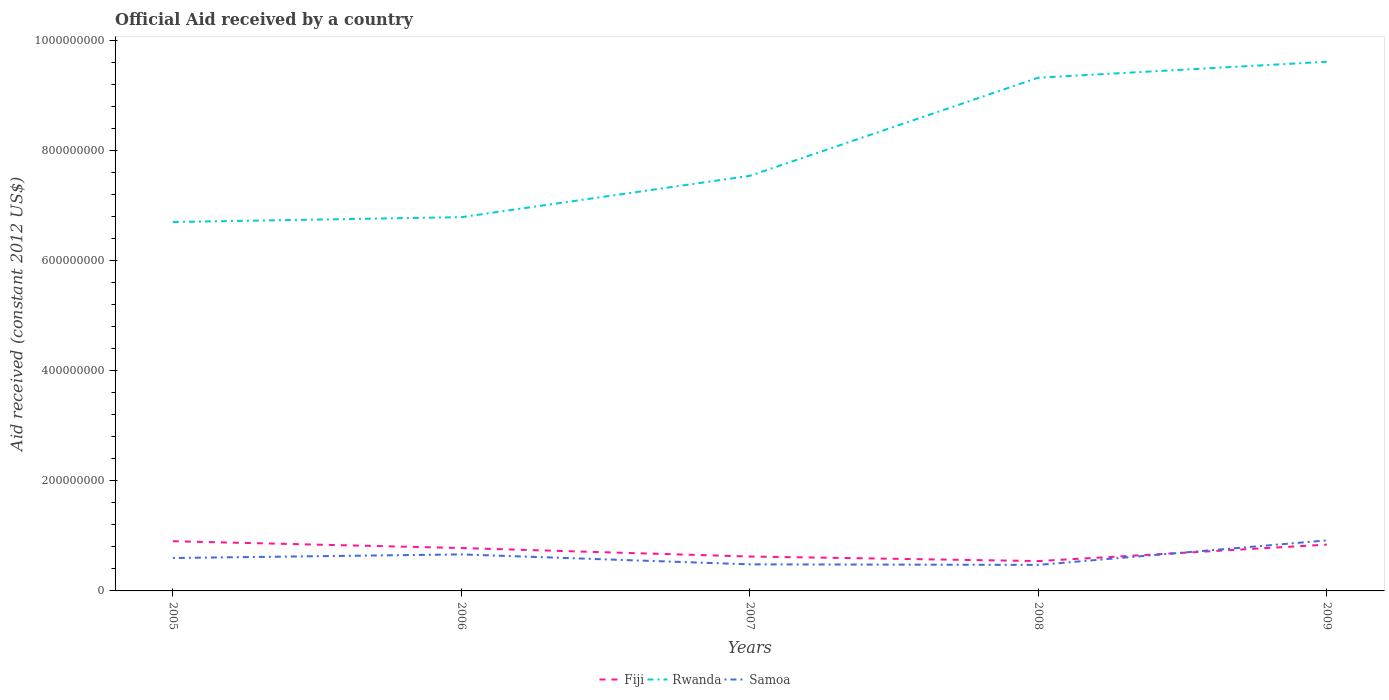How many different coloured lines are there?
Your answer should be very brief. 3. Does the line corresponding to Fiji intersect with the line corresponding to Samoa?
Provide a succinct answer. Yes. Across all years, what is the maximum net official aid received in Rwanda?
Offer a terse response. 6.70e+08. What is the total net official aid received in Fiji in the graph?
Make the answer very short. -2.99e+07. What is the difference between the highest and the second highest net official aid received in Samoa?
Your answer should be very brief. 4.45e+07. Is the net official aid received in Samoa strictly greater than the net official aid received in Rwanda over the years?
Your answer should be compact. Yes. How many lines are there?
Ensure brevity in your answer.  3. How many years are there in the graph?
Make the answer very short. 5. Are the values on the major ticks of Y-axis written in scientific E-notation?
Keep it short and to the point. No. Where does the legend appear in the graph?
Your answer should be very brief. Bottom center. How many legend labels are there?
Offer a very short reply. 3. How are the legend labels stacked?
Your response must be concise. Horizontal. What is the title of the graph?
Ensure brevity in your answer.  Official Aid received by a country. Does "Bangladesh" appear as one of the legend labels in the graph?
Your answer should be compact. No. What is the label or title of the X-axis?
Your answer should be compact. Years. What is the label or title of the Y-axis?
Your response must be concise. Aid received (constant 2012 US$). What is the Aid received (constant 2012 US$) in Fiji in 2005?
Offer a very short reply. 9.03e+07. What is the Aid received (constant 2012 US$) in Rwanda in 2005?
Provide a succinct answer. 6.70e+08. What is the Aid received (constant 2012 US$) of Samoa in 2005?
Give a very brief answer. 5.98e+07. What is the Aid received (constant 2012 US$) in Fiji in 2006?
Keep it short and to the point. 7.79e+07. What is the Aid received (constant 2012 US$) of Rwanda in 2006?
Ensure brevity in your answer.  6.79e+08. What is the Aid received (constant 2012 US$) in Samoa in 2006?
Your answer should be compact. 6.63e+07. What is the Aid received (constant 2012 US$) of Fiji in 2007?
Give a very brief answer. 6.25e+07. What is the Aid received (constant 2012 US$) of Rwanda in 2007?
Provide a succinct answer. 7.54e+08. What is the Aid received (constant 2012 US$) of Samoa in 2007?
Provide a succinct answer. 4.83e+07. What is the Aid received (constant 2012 US$) of Fiji in 2008?
Keep it short and to the point. 5.42e+07. What is the Aid received (constant 2012 US$) of Rwanda in 2008?
Keep it short and to the point. 9.32e+08. What is the Aid received (constant 2012 US$) of Samoa in 2008?
Provide a succinct answer. 4.73e+07. What is the Aid received (constant 2012 US$) in Fiji in 2009?
Offer a terse response. 8.41e+07. What is the Aid received (constant 2012 US$) in Rwanda in 2009?
Your response must be concise. 9.61e+08. What is the Aid received (constant 2012 US$) in Samoa in 2009?
Your answer should be compact. 9.18e+07. Across all years, what is the maximum Aid received (constant 2012 US$) of Fiji?
Provide a short and direct response. 9.03e+07. Across all years, what is the maximum Aid received (constant 2012 US$) in Rwanda?
Offer a terse response. 9.61e+08. Across all years, what is the maximum Aid received (constant 2012 US$) of Samoa?
Provide a short and direct response. 9.18e+07. Across all years, what is the minimum Aid received (constant 2012 US$) in Fiji?
Make the answer very short. 5.42e+07. Across all years, what is the minimum Aid received (constant 2012 US$) of Rwanda?
Offer a terse response. 6.70e+08. Across all years, what is the minimum Aid received (constant 2012 US$) in Samoa?
Offer a very short reply. 4.73e+07. What is the total Aid received (constant 2012 US$) in Fiji in the graph?
Offer a terse response. 3.69e+08. What is the total Aid received (constant 2012 US$) of Rwanda in the graph?
Your response must be concise. 4.00e+09. What is the total Aid received (constant 2012 US$) of Samoa in the graph?
Keep it short and to the point. 3.13e+08. What is the difference between the Aid received (constant 2012 US$) in Fiji in 2005 and that in 2006?
Provide a short and direct response. 1.24e+07. What is the difference between the Aid received (constant 2012 US$) in Rwanda in 2005 and that in 2006?
Offer a terse response. -8.83e+06. What is the difference between the Aid received (constant 2012 US$) of Samoa in 2005 and that in 2006?
Your response must be concise. -6.54e+06. What is the difference between the Aid received (constant 2012 US$) in Fiji in 2005 and that in 2007?
Give a very brief answer. 2.78e+07. What is the difference between the Aid received (constant 2012 US$) of Rwanda in 2005 and that in 2007?
Make the answer very short. -8.39e+07. What is the difference between the Aid received (constant 2012 US$) in Samoa in 2005 and that in 2007?
Provide a short and direct response. 1.15e+07. What is the difference between the Aid received (constant 2012 US$) in Fiji in 2005 and that in 2008?
Make the answer very short. 3.60e+07. What is the difference between the Aid received (constant 2012 US$) of Rwanda in 2005 and that in 2008?
Provide a short and direct response. -2.62e+08. What is the difference between the Aid received (constant 2012 US$) in Samoa in 2005 and that in 2008?
Provide a short and direct response. 1.25e+07. What is the difference between the Aid received (constant 2012 US$) of Fiji in 2005 and that in 2009?
Make the answer very short. 6.16e+06. What is the difference between the Aid received (constant 2012 US$) in Rwanda in 2005 and that in 2009?
Offer a very short reply. -2.91e+08. What is the difference between the Aid received (constant 2012 US$) in Samoa in 2005 and that in 2009?
Make the answer very short. -3.20e+07. What is the difference between the Aid received (constant 2012 US$) in Fiji in 2006 and that in 2007?
Ensure brevity in your answer.  1.54e+07. What is the difference between the Aid received (constant 2012 US$) in Rwanda in 2006 and that in 2007?
Make the answer very short. -7.50e+07. What is the difference between the Aid received (constant 2012 US$) of Samoa in 2006 and that in 2007?
Offer a very short reply. 1.80e+07. What is the difference between the Aid received (constant 2012 US$) in Fiji in 2006 and that in 2008?
Make the answer very short. 2.37e+07. What is the difference between the Aid received (constant 2012 US$) of Rwanda in 2006 and that in 2008?
Give a very brief answer. -2.53e+08. What is the difference between the Aid received (constant 2012 US$) in Samoa in 2006 and that in 2008?
Make the answer very short. 1.91e+07. What is the difference between the Aid received (constant 2012 US$) in Fiji in 2006 and that in 2009?
Provide a succinct answer. -6.22e+06. What is the difference between the Aid received (constant 2012 US$) of Rwanda in 2006 and that in 2009?
Your answer should be compact. -2.82e+08. What is the difference between the Aid received (constant 2012 US$) in Samoa in 2006 and that in 2009?
Keep it short and to the point. -2.54e+07. What is the difference between the Aid received (constant 2012 US$) of Fiji in 2007 and that in 2008?
Your answer should be very brief. 8.26e+06. What is the difference between the Aid received (constant 2012 US$) in Rwanda in 2007 and that in 2008?
Keep it short and to the point. -1.78e+08. What is the difference between the Aid received (constant 2012 US$) of Samoa in 2007 and that in 2008?
Offer a very short reply. 1.01e+06. What is the difference between the Aid received (constant 2012 US$) of Fiji in 2007 and that in 2009?
Your answer should be very brief. -2.16e+07. What is the difference between the Aid received (constant 2012 US$) of Rwanda in 2007 and that in 2009?
Make the answer very short. -2.07e+08. What is the difference between the Aid received (constant 2012 US$) of Samoa in 2007 and that in 2009?
Your answer should be compact. -4.35e+07. What is the difference between the Aid received (constant 2012 US$) in Fiji in 2008 and that in 2009?
Provide a short and direct response. -2.99e+07. What is the difference between the Aid received (constant 2012 US$) of Rwanda in 2008 and that in 2009?
Give a very brief answer. -2.90e+07. What is the difference between the Aid received (constant 2012 US$) of Samoa in 2008 and that in 2009?
Your answer should be very brief. -4.45e+07. What is the difference between the Aid received (constant 2012 US$) of Fiji in 2005 and the Aid received (constant 2012 US$) of Rwanda in 2006?
Keep it short and to the point. -5.89e+08. What is the difference between the Aid received (constant 2012 US$) in Fiji in 2005 and the Aid received (constant 2012 US$) in Samoa in 2006?
Keep it short and to the point. 2.40e+07. What is the difference between the Aid received (constant 2012 US$) in Rwanda in 2005 and the Aid received (constant 2012 US$) in Samoa in 2006?
Keep it short and to the point. 6.04e+08. What is the difference between the Aid received (constant 2012 US$) of Fiji in 2005 and the Aid received (constant 2012 US$) of Rwanda in 2007?
Your answer should be compact. -6.64e+08. What is the difference between the Aid received (constant 2012 US$) in Fiji in 2005 and the Aid received (constant 2012 US$) in Samoa in 2007?
Your answer should be compact. 4.20e+07. What is the difference between the Aid received (constant 2012 US$) of Rwanda in 2005 and the Aid received (constant 2012 US$) of Samoa in 2007?
Provide a succinct answer. 6.22e+08. What is the difference between the Aid received (constant 2012 US$) of Fiji in 2005 and the Aid received (constant 2012 US$) of Rwanda in 2008?
Ensure brevity in your answer.  -8.42e+08. What is the difference between the Aid received (constant 2012 US$) of Fiji in 2005 and the Aid received (constant 2012 US$) of Samoa in 2008?
Offer a very short reply. 4.30e+07. What is the difference between the Aid received (constant 2012 US$) of Rwanda in 2005 and the Aid received (constant 2012 US$) of Samoa in 2008?
Offer a terse response. 6.23e+08. What is the difference between the Aid received (constant 2012 US$) of Fiji in 2005 and the Aid received (constant 2012 US$) of Rwanda in 2009?
Make the answer very short. -8.71e+08. What is the difference between the Aid received (constant 2012 US$) in Fiji in 2005 and the Aid received (constant 2012 US$) in Samoa in 2009?
Make the answer very short. -1.48e+06. What is the difference between the Aid received (constant 2012 US$) in Rwanda in 2005 and the Aid received (constant 2012 US$) in Samoa in 2009?
Ensure brevity in your answer.  5.78e+08. What is the difference between the Aid received (constant 2012 US$) in Fiji in 2006 and the Aid received (constant 2012 US$) in Rwanda in 2007?
Keep it short and to the point. -6.76e+08. What is the difference between the Aid received (constant 2012 US$) of Fiji in 2006 and the Aid received (constant 2012 US$) of Samoa in 2007?
Ensure brevity in your answer.  2.96e+07. What is the difference between the Aid received (constant 2012 US$) in Rwanda in 2006 and the Aid received (constant 2012 US$) in Samoa in 2007?
Provide a short and direct response. 6.31e+08. What is the difference between the Aid received (constant 2012 US$) in Fiji in 2006 and the Aid received (constant 2012 US$) in Rwanda in 2008?
Provide a short and direct response. -8.54e+08. What is the difference between the Aid received (constant 2012 US$) in Fiji in 2006 and the Aid received (constant 2012 US$) in Samoa in 2008?
Offer a very short reply. 3.06e+07. What is the difference between the Aid received (constant 2012 US$) of Rwanda in 2006 and the Aid received (constant 2012 US$) of Samoa in 2008?
Offer a very short reply. 6.32e+08. What is the difference between the Aid received (constant 2012 US$) of Fiji in 2006 and the Aid received (constant 2012 US$) of Rwanda in 2009?
Offer a terse response. -8.83e+08. What is the difference between the Aid received (constant 2012 US$) in Fiji in 2006 and the Aid received (constant 2012 US$) in Samoa in 2009?
Your response must be concise. -1.39e+07. What is the difference between the Aid received (constant 2012 US$) of Rwanda in 2006 and the Aid received (constant 2012 US$) of Samoa in 2009?
Give a very brief answer. 5.87e+08. What is the difference between the Aid received (constant 2012 US$) in Fiji in 2007 and the Aid received (constant 2012 US$) in Rwanda in 2008?
Provide a short and direct response. -8.70e+08. What is the difference between the Aid received (constant 2012 US$) in Fiji in 2007 and the Aid received (constant 2012 US$) in Samoa in 2008?
Offer a very short reply. 1.52e+07. What is the difference between the Aid received (constant 2012 US$) in Rwanda in 2007 and the Aid received (constant 2012 US$) in Samoa in 2008?
Offer a terse response. 7.07e+08. What is the difference between the Aid received (constant 2012 US$) of Fiji in 2007 and the Aid received (constant 2012 US$) of Rwanda in 2009?
Provide a succinct answer. -8.99e+08. What is the difference between the Aid received (constant 2012 US$) in Fiji in 2007 and the Aid received (constant 2012 US$) in Samoa in 2009?
Your response must be concise. -2.93e+07. What is the difference between the Aid received (constant 2012 US$) in Rwanda in 2007 and the Aid received (constant 2012 US$) in Samoa in 2009?
Keep it short and to the point. 6.62e+08. What is the difference between the Aid received (constant 2012 US$) of Fiji in 2008 and the Aid received (constant 2012 US$) of Rwanda in 2009?
Offer a terse response. -9.07e+08. What is the difference between the Aid received (constant 2012 US$) of Fiji in 2008 and the Aid received (constant 2012 US$) of Samoa in 2009?
Make the answer very short. -3.75e+07. What is the difference between the Aid received (constant 2012 US$) in Rwanda in 2008 and the Aid received (constant 2012 US$) in Samoa in 2009?
Provide a short and direct response. 8.40e+08. What is the average Aid received (constant 2012 US$) in Fiji per year?
Offer a very short reply. 7.38e+07. What is the average Aid received (constant 2012 US$) of Rwanda per year?
Give a very brief answer. 7.99e+08. What is the average Aid received (constant 2012 US$) of Samoa per year?
Make the answer very short. 6.27e+07. In the year 2005, what is the difference between the Aid received (constant 2012 US$) of Fiji and Aid received (constant 2012 US$) of Rwanda?
Ensure brevity in your answer.  -5.80e+08. In the year 2005, what is the difference between the Aid received (constant 2012 US$) of Fiji and Aid received (constant 2012 US$) of Samoa?
Make the answer very short. 3.05e+07. In the year 2005, what is the difference between the Aid received (constant 2012 US$) in Rwanda and Aid received (constant 2012 US$) in Samoa?
Give a very brief answer. 6.10e+08. In the year 2006, what is the difference between the Aid received (constant 2012 US$) in Fiji and Aid received (constant 2012 US$) in Rwanda?
Your answer should be compact. -6.01e+08. In the year 2006, what is the difference between the Aid received (constant 2012 US$) in Fiji and Aid received (constant 2012 US$) in Samoa?
Your answer should be very brief. 1.16e+07. In the year 2006, what is the difference between the Aid received (constant 2012 US$) in Rwanda and Aid received (constant 2012 US$) in Samoa?
Provide a short and direct response. 6.13e+08. In the year 2007, what is the difference between the Aid received (constant 2012 US$) in Fiji and Aid received (constant 2012 US$) in Rwanda?
Make the answer very short. -6.91e+08. In the year 2007, what is the difference between the Aid received (constant 2012 US$) of Fiji and Aid received (constant 2012 US$) of Samoa?
Provide a succinct answer. 1.42e+07. In the year 2007, what is the difference between the Aid received (constant 2012 US$) in Rwanda and Aid received (constant 2012 US$) in Samoa?
Ensure brevity in your answer.  7.06e+08. In the year 2008, what is the difference between the Aid received (constant 2012 US$) in Fiji and Aid received (constant 2012 US$) in Rwanda?
Your answer should be very brief. -8.78e+08. In the year 2008, what is the difference between the Aid received (constant 2012 US$) in Fiji and Aid received (constant 2012 US$) in Samoa?
Provide a short and direct response. 6.96e+06. In the year 2008, what is the difference between the Aid received (constant 2012 US$) of Rwanda and Aid received (constant 2012 US$) of Samoa?
Provide a succinct answer. 8.85e+08. In the year 2009, what is the difference between the Aid received (constant 2012 US$) of Fiji and Aid received (constant 2012 US$) of Rwanda?
Your answer should be very brief. -8.77e+08. In the year 2009, what is the difference between the Aid received (constant 2012 US$) in Fiji and Aid received (constant 2012 US$) in Samoa?
Your answer should be very brief. -7.64e+06. In the year 2009, what is the difference between the Aid received (constant 2012 US$) in Rwanda and Aid received (constant 2012 US$) in Samoa?
Ensure brevity in your answer.  8.69e+08. What is the ratio of the Aid received (constant 2012 US$) in Fiji in 2005 to that in 2006?
Your answer should be compact. 1.16. What is the ratio of the Aid received (constant 2012 US$) of Samoa in 2005 to that in 2006?
Offer a very short reply. 0.9. What is the ratio of the Aid received (constant 2012 US$) of Fiji in 2005 to that in 2007?
Provide a short and direct response. 1.44. What is the ratio of the Aid received (constant 2012 US$) of Rwanda in 2005 to that in 2007?
Offer a terse response. 0.89. What is the ratio of the Aid received (constant 2012 US$) in Samoa in 2005 to that in 2007?
Your response must be concise. 1.24. What is the ratio of the Aid received (constant 2012 US$) of Fiji in 2005 to that in 2008?
Ensure brevity in your answer.  1.66. What is the ratio of the Aid received (constant 2012 US$) of Rwanda in 2005 to that in 2008?
Offer a very short reply. 0.72. What is the ratio of the Aid received (constant 2012 US$) of Samoa in 2005 to that in 2008?
Your response must be concise. 1.26. What is the ratio of the Aid received (constant 2012 US$) of Fiji in 2005 to that in 2009?
Your response must be concise. 1.07. What is the ratio of the Aid received (constant 2012 US$) in Rwanda in 2005 to that in 2009?
Offer a very short reply. 0.7. What is the ratio of the Aid received (constant 2012 US$) in Samoa in 2005 to that in 2009?
Provide a short and direct response. 0.65. What is the ratio of the Aid received (constant 2012 US$) of Fiji in 2006 to that in 2007?
Your answer should be compact. 1.25. What is the ratio of the Aid received (constant 2012 US$) in Rwanda in 2006 to that in 2007?
Give a very brief answer. 0.9. What is the ratio of the Aid received (constant 2012 US$) of Samoa in 2006 to that in 2007?
Make the answer very short. 1.37. What is the ratio of the Aid received (constant 2012 US$) in Fiji in 2006 to that in 2008?
Your answer should be very brief. 1.44. What is the ratio of the Aid received (constant 2012 US$) in Rwanda in 2006 to that in 2008?
Your answer should be compact. 0.73. What is the ratio of the Aid received (constant 2012 US$) in Samoa in 2006 to that in 2008?
Provide a short and direct response. 1.4. What is the ratio of the Aid received (constant 2012 US$) of Fiji in 2006 to that in 2009?
Keep it short and to the point. 0.93. What is the ratio of the Aid received (constant 2012 US$) of Rwanda in 2006 to that in 2009?
Your answer should be compact. 0.71. What is the ratio of the Aid received (constant 2012 US$) in Samoa in 2006 to that in 2009?
Give a very brief answer. 0.72. What is the ratio of the Aid received (constant 2012 US$) in Fiji in 2007 to that in 2008?
Give a very brief answer. 1.15. What is the ratio of the Aid received (constant 2012 US$) of Rwanda in 2007 to that in 2008?
Your answer should be compact. 0.81. What is the ratio of the Aid received (constant 2012 US$) of Samoa in 2007 to that in 2008?
Your answer should be very brief. 1.02. What is the ratio of the Aid received (constant 2012 US$) in Fiji in 2007 to that in 2009?
Your response must be concise. 0.74. What is the ratio of the Aid received (constant 2012 US$) in Rwanda in 2007 to that in 2009?
Make the answer very short. 0.78. What is the ratio of the Aid received (constant 2012 US$) of Samoa in 2007 to that in 2009?
Offer a very short reply. 0.53. What is the ratio of the Aid received (constant 2012 US$) of Fiji in 2008 to that in 2009?
Provide a succinct answer. 0.64. What is the ratio of the Aid received (constant 2012 US$) of Rwanda in 2008 to that in 2009?
Offer a very short reply. 0.97. What is the ratio of the Aid received (constant 2012 US$) in Samoa in 2008 to that in 2009?
Provide a short and direct response. 0.52. What is the difference between the highest and the second highest Aid received (constant 2012 US$) in Fiji?
Keep it short and to the point. 6.16e+06. What is the difference between the highest and the second highest Aid received (constant 2012 US$) of Rwanda?
Your answer should be very brief. 2.90e+07. What is the difference between the highest and the second highest Aid received (constant 2012 US$) of Samoa?
Provide a succinct answer. 2.54e+07. What is the difference between the highest and the lowest Aid received (constant 2012 US$) of Fiji?
Your response must be concise. 3.60e+07. What is the difference between the highest and the lowest Aid received (constant 2012 US$) of Rwanda?
Provide a succinct answer. 2.91e+08. What is the difference between the highest and the lowest Aid received (constant 2012 US$) in Samoa?
Provide a short and direct response. 4.45e+07. 